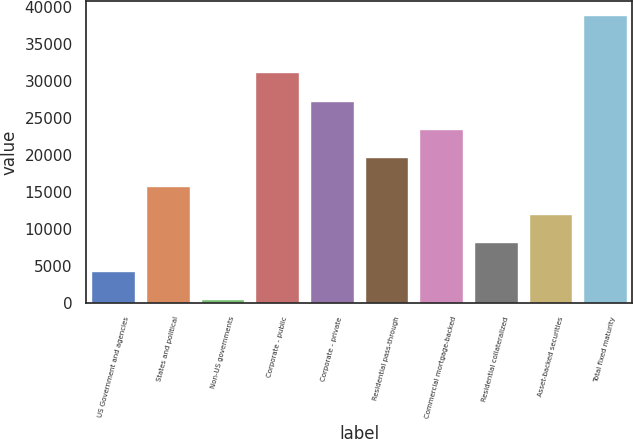<chart> <loc_0><loc_0><loc_500><loc_500><bar_chart><fcel>US Government and agencies<fcel>States and political<fcel>Non-US governments<fcel>Corporate - public<fcel>Corporate - private<fcel>Residential pass-through<fcel>Commercial mortgage-backed<fcel>Residential collateralized<fcel>Asset-backed securities<fcel>Total fixed maturity<nl><fcel>4313.29<fcel>15817.7<fcel>478.5<fcel>31156.8<fcel>27322<fcel>19652.5<fcel>23487.2<fcel>8148.08<fcel>11982.9<fcel>38826.4<nl></chart> 